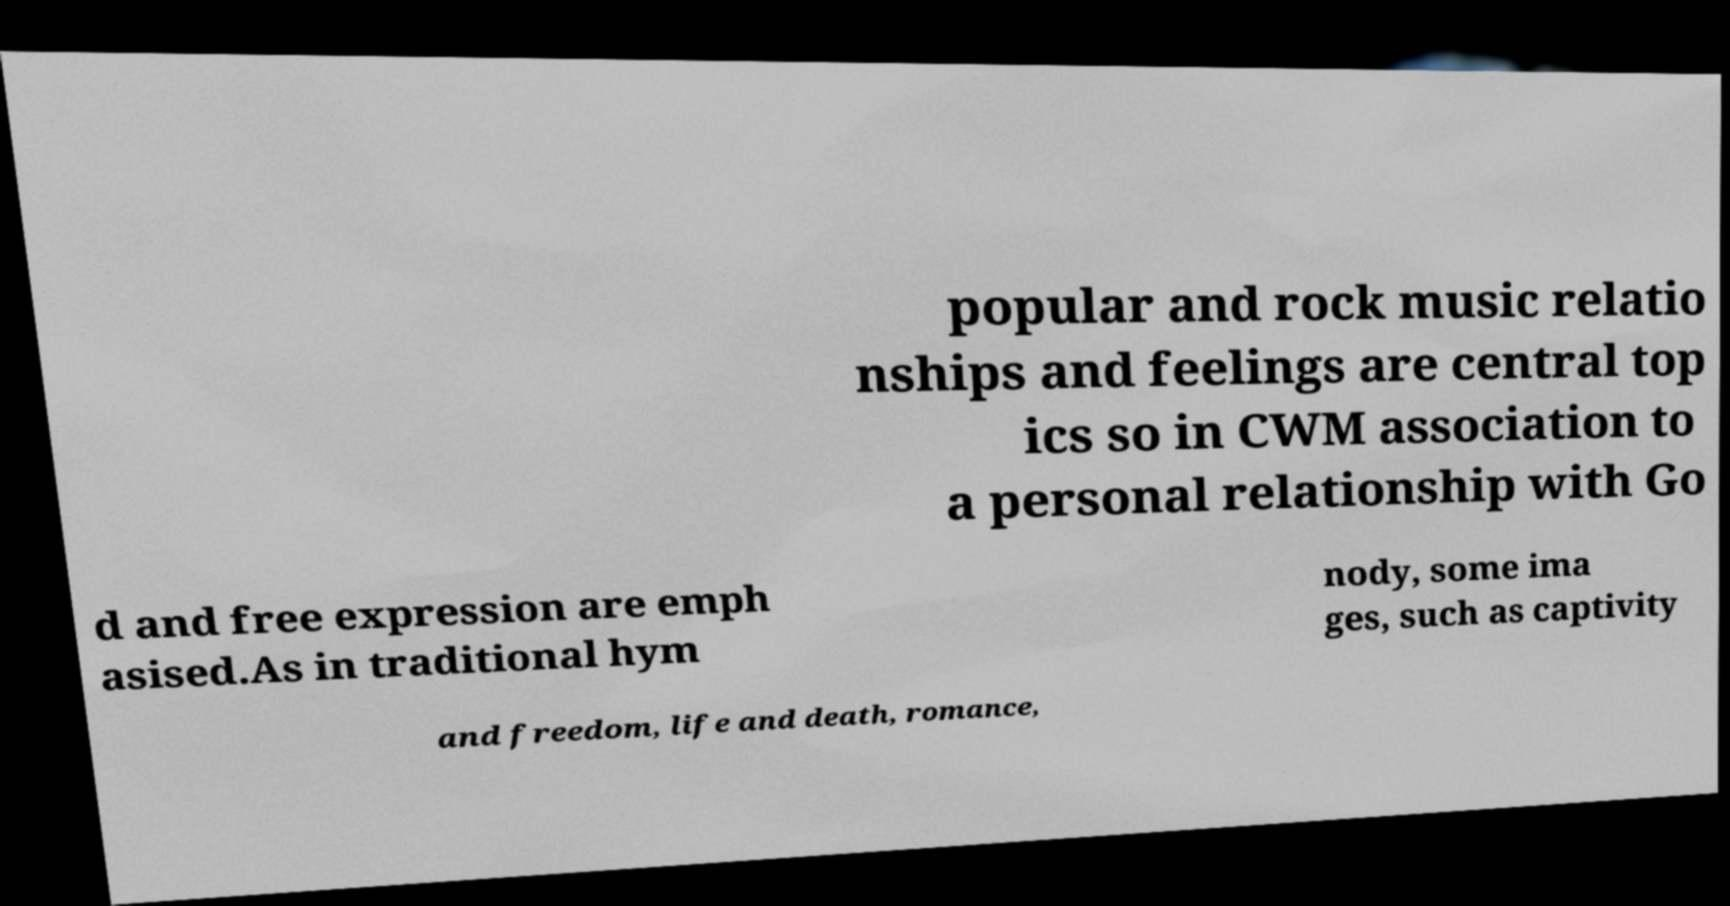Please read and relay the text visible in this image. What does it say? popular and rock music relatio nships and feelings are central top ics so in CWM association to a personal relationship with Go d and free expression are emph asised.As in traditional hym nody, some ima ges, such as captivity and freedom, life and death, romance, 